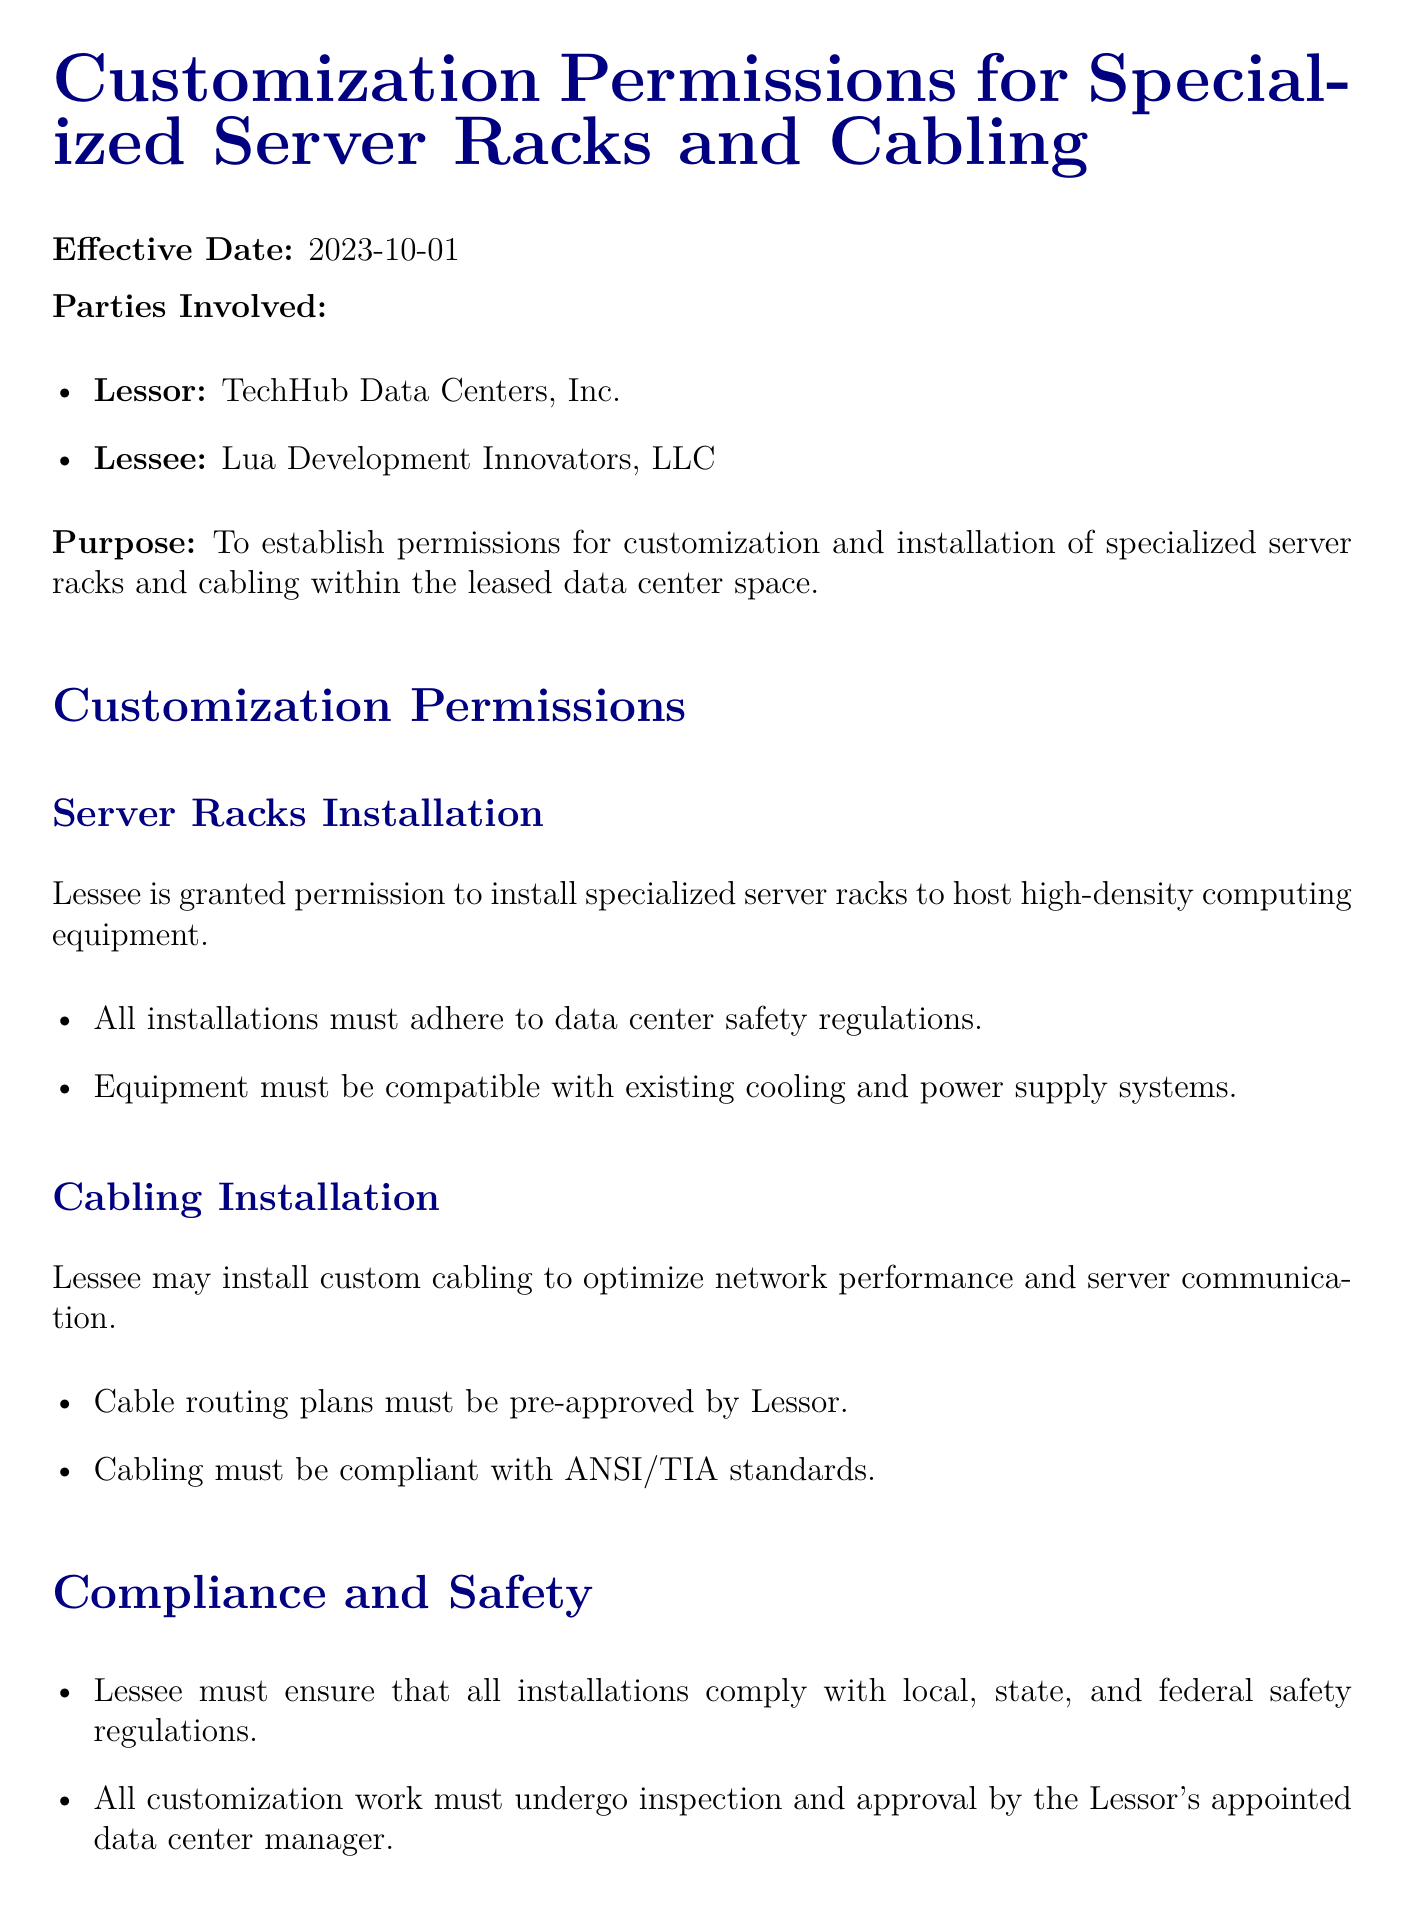what is the effective date of the lease agreement? The effective date is mentioned at the top of the document as the commencement of the permissions.
Answer: 2023-10-01 who is the lessor in this agreement? The lessor's name is explicitly stated in the parties involved section of the document.
Answer: TechHub Data Centers, Inc what must all installations adhere to according to the server racks installation section? This requirement is stated under server racks installation permissions in the document.
Answer: data center safety regulations what standards must the cabling comply with? This is specified in the cabling installation section regarding compliance.
Answer: ANSI/TIA standards how many days does the lessee have to restore the data center space after lease termination? This duration is explicitly mentioned in the termination section of the document.
Answer: 30 days who is responsible for ensuring the maintenance of the installed equipment? This responsibility is outlined in the maintenance and support section of the lease agreement.
Answer: Lessee what is the lessee required to do in case of claims arising from custom installations? This obligation is stated in the termination and indemnification section regarding protection of the lessor.
Answer: indemnify and hold harmless what is the purpose of this lease agreement? The purpose is articulated at the beginning of the document.
Answer: establish permissions for customization and installation of specialized server racks and cabling 